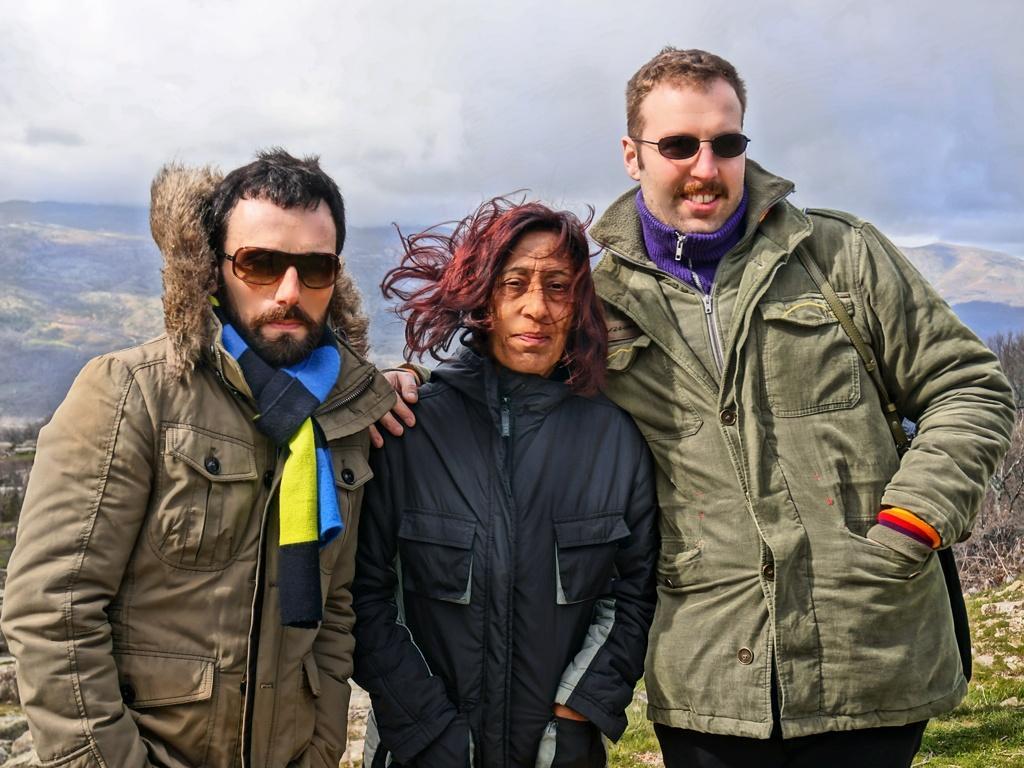Describe this image in one or two sentences. In this picture we can see there are three people standing and behind the people there are trees, hills and the sky. 